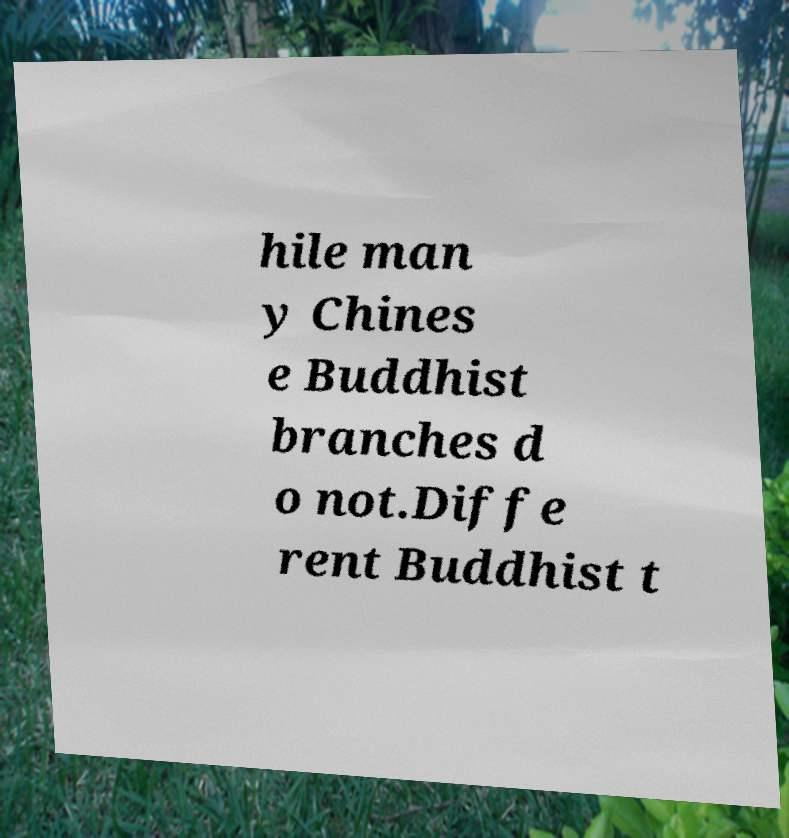Please identify and transcribe the text found in this image. hile man y Chines e Buddhist branches d o not.Diffe rent Buddhist t 